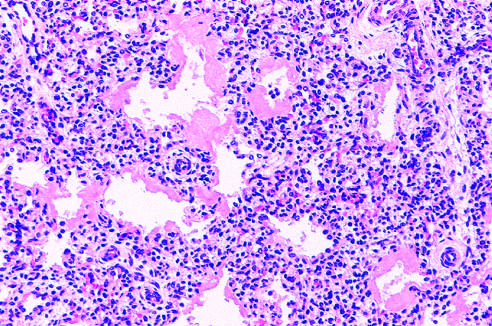what is hematoxylin-eosin stain?
Answer the question using a single word or phrase. Hyaline membrane disease 